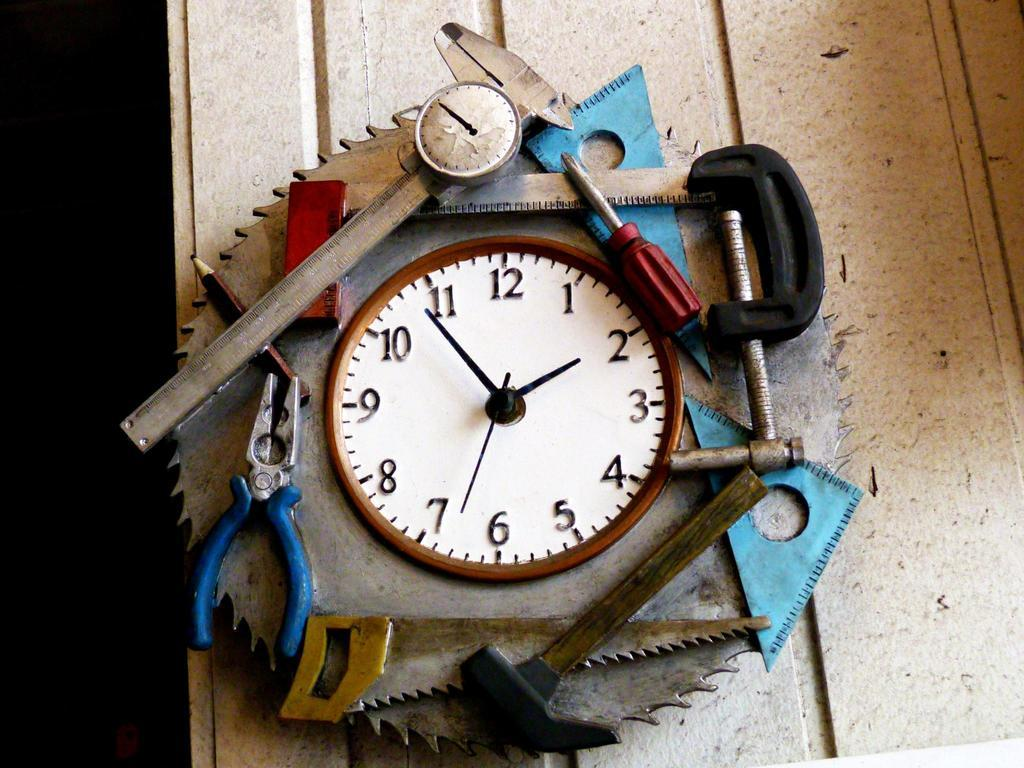What type of furniture is present in the image? There is a table in the image. What is placed on the table? There is a machine on the table. What is featured on the machine? There is a clock on the machine. What can be seen around the clock on the machine? There are objects placed around the clock. What type of calculator is being used for hobbies in the image? There is no calculator or reference to hobbies in the image; it features a machine with a clock and objects around it. 